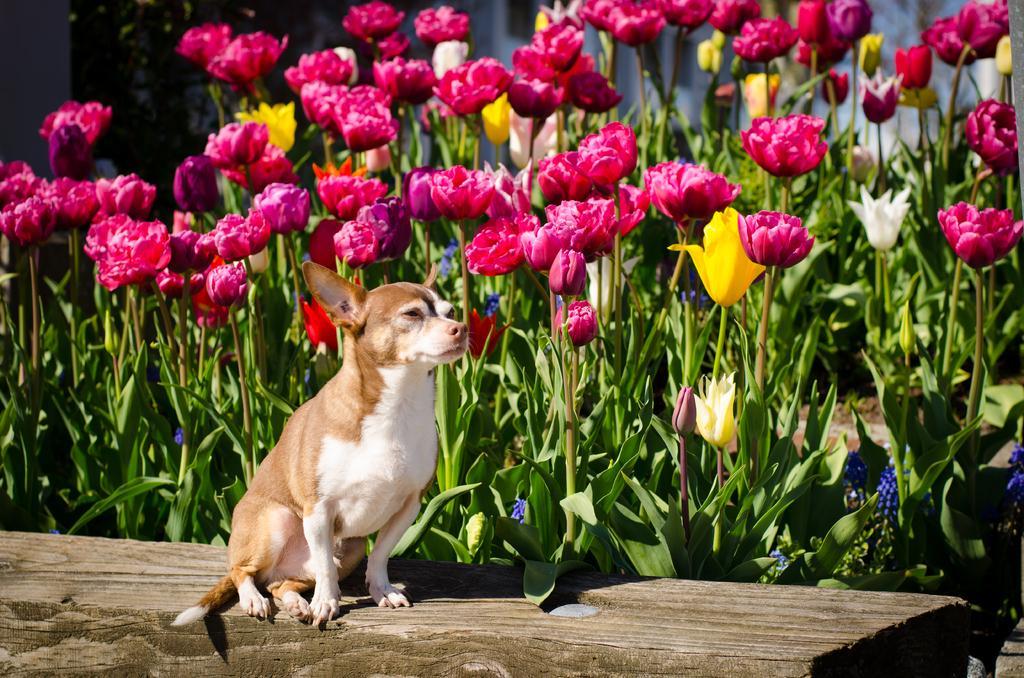Describe this image in one or two sentences. Here in the middle we can see a dog present on a bench over there and beside it we can see rose flowers and plants present all over there. 